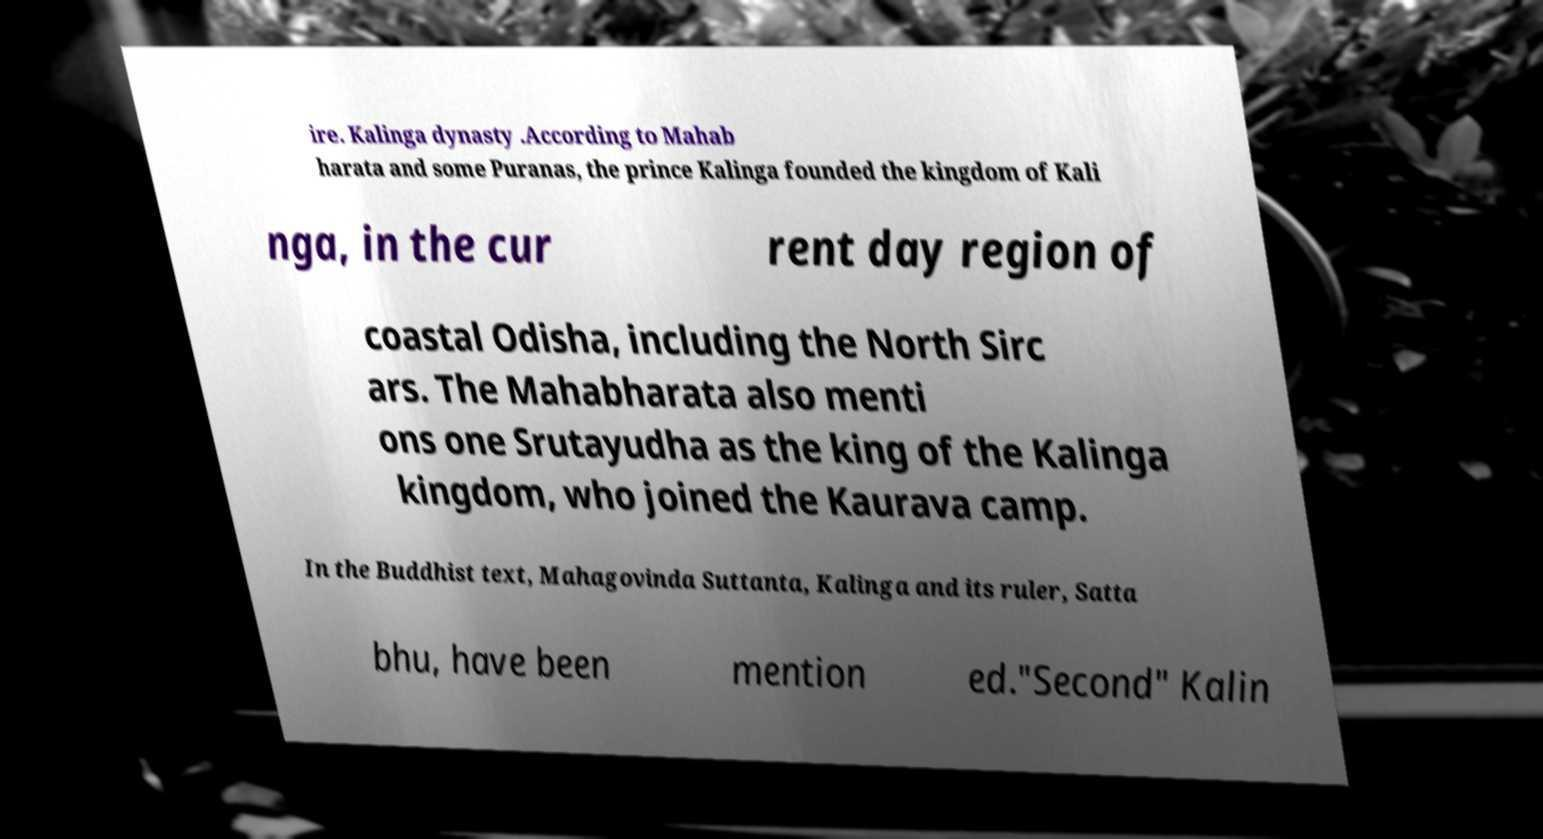Please read and relay the text visible in this image. What does it say? ire. Kalinga dynasty .According to Mahab harata and some Puranas, the prince Kalinga founded the kingdom of Kali nga, in the cur rent day region of coastal Odisha, including the North Sirc ars. The Mahabharata also menti ons one Srutayudha as the king of the Kalinga kingdom, who joined the Kaurava camp. In the Buddhist text, Mahagovinda Suttanta, Kalinga and its ruler, Satta bhu, have been mention ed."Second" Kalin 